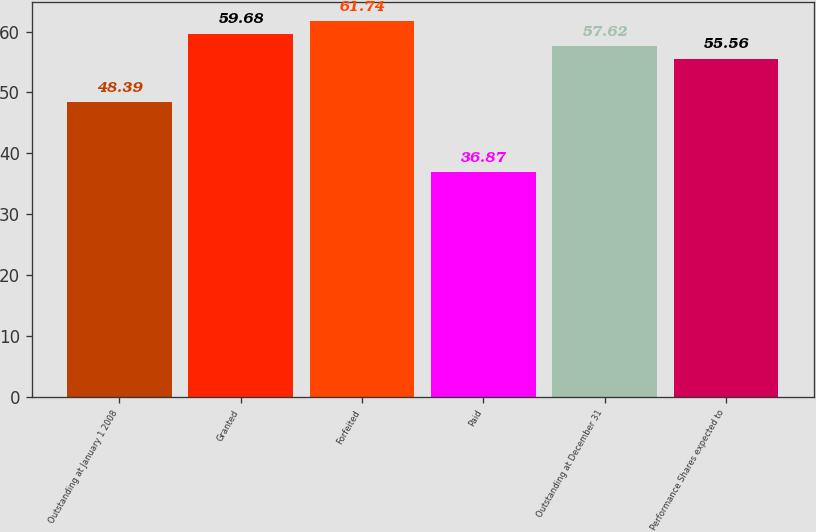Convert chart. <chart><loc_0><loc_0><loc_500><loc_500><bar_chart><fcel>Outstanding at January 1 2008<fcel>Granted<fcel>Forfeited<fcel>Paid<fcel>Outstanding at December 31<fcel>Performance Shares expected to<nl><fcel>48.39<fcel>59.68<fcel>61.74<fcel>36.87<fcel>57.62<fcel>55.56<nl></chart> 